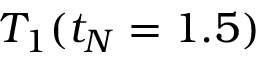<formula> <loc_0><loc_0><loc_500><loc_500>T _ { 1 } ( t _ { N } = 1 . 5 )</formula> 